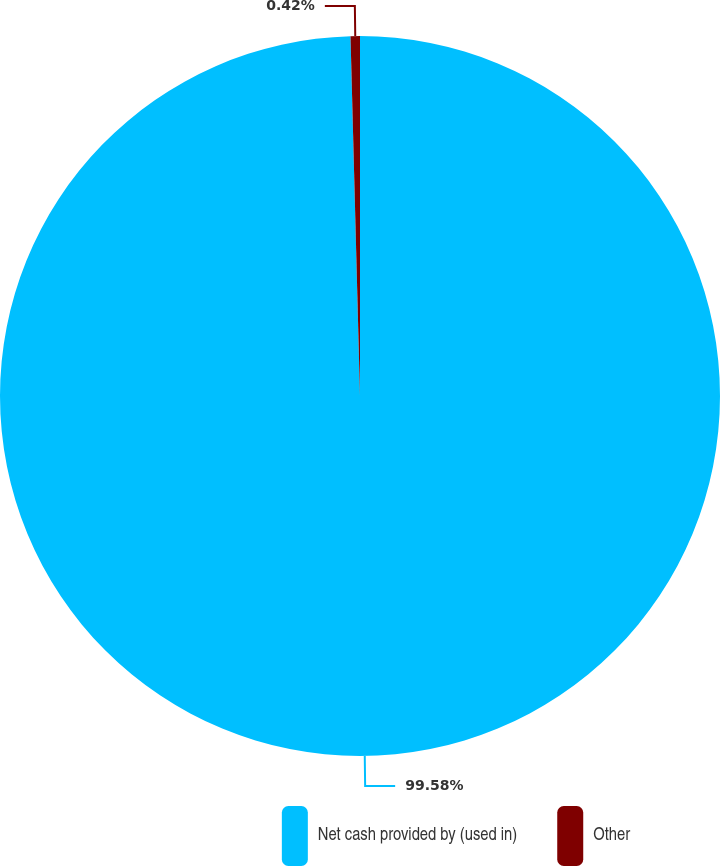Convert chart. <chart><loc_0><loc_0><loc_500><loc_500><pie_chart><fcel>Net cash provided by (used in)<fcel>Other<nl><fcel>99.58%<fcel>0.42%<nl></chart> 